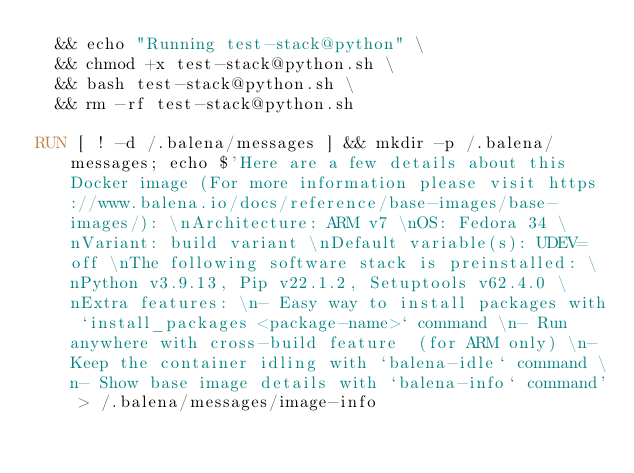Convert code to text. <code><loc_0><loc_0><loc_500><loc_500><_Dockerfile_>  && echo "Running test-stack@python" \
  && chmod +x test-stack@python.sh \
  && bash test-stack@python.sh \
  && rm -rf test-stack@python.sh 

RUN [ ! -d /.balena/messages ] && mkdir -p /.balena/messages; echo $'Here are a few details about this Docker image (For more information please visit https://www.balena.io/docs/reference/base-images/base-images/): \nArchitecture: ARM v7 \nOS: Fedora 34 \nVariant: build variant \nDefault variable(s): UDEV=off \nThe following software stack is preinstalled: \nPython v3.9.13, Pip v22.1.2, Setuptools v62.4.0 \nExtra features: \n- Easy way to install packages with `install_packages <package-name>` command \n- Run anywhere with cross-build feature  (for ARM only) \n- Keep the container idling with `balena-idle` command \n- Show base image details with `balena-info` command' > /.balena/messages/image-info</code> 